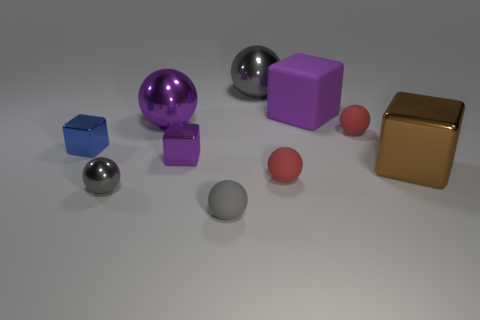Subtract all cyan cylinders. How many gray balls are left? 3 Subtract 1 cubes. How many cubes are left? 3 Subtract all red balls. How many balls are left? 4 Subtract all red balls. How many balls are left? 4 Subtract all brown spheres. Subtract all cyan blocks. How many spheres are left? 6 Subtract all balls. How many objects are left? 4 Add 7 small red rubber spheres. How many small red rubber spheres are left? 9 Add 4 tiny gray shiny spheres. How many tiny gray shiny spheres exist? 5 Subtract 0 gray cubes. How many objects are left? 10 Subtract all large balls. Subtract all small blue shiny objects. How many objects are left? 7 